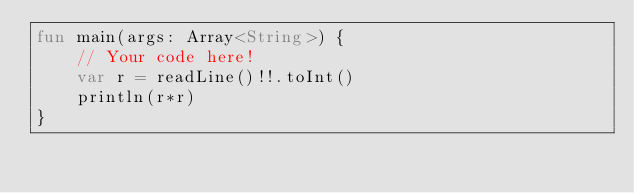Convert code to text. <code><loc_0><loc_0><loc_500><loc_500><_Kotlin_>fun main(args: Array<String>) {
    // Your code here!
    var r = readLine()!!.toInt()
    println(r*r)
}
</code> 